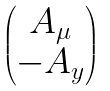Convert formula to latex. <formula><loc_0><loc_0><loc_500><loc_500>\begin{pmatrix} A _ { \mu } \\ - A _ { y } \end{pmatrix}</formula> 